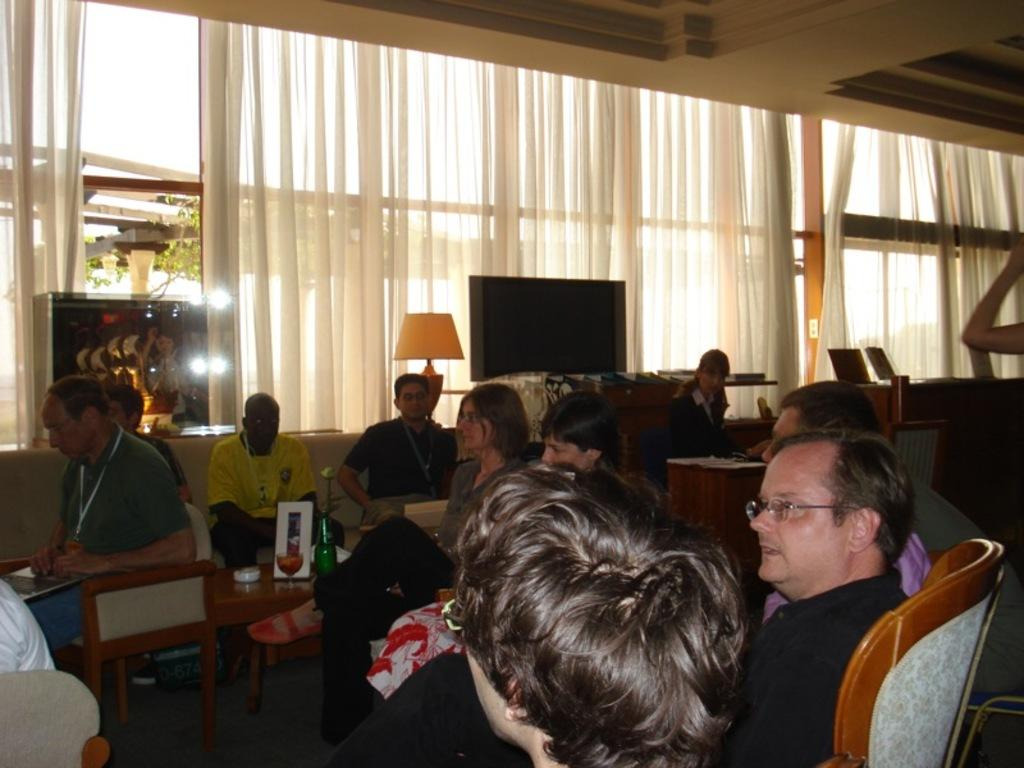How many people are in the image? There is a group of people in the image. What are the people doing in the image? The people are seated on chairs. What electronic device is present in the image? There is a television in the image. What type of window treatment is visible in the image? There are curtains in the image. What type of pollution can be seen in the image? There is no pollution present in the image. What story is being told by the people in the image? The image does not provide any information about a story being told by the people. 